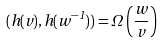<formula> <loc_0><loc_0><loc_500><loc_500>( h ( v ) , h ( w ^ { - 1 } ) ) = \Omega \left ( \frac { w } { v } \right )</formula> 